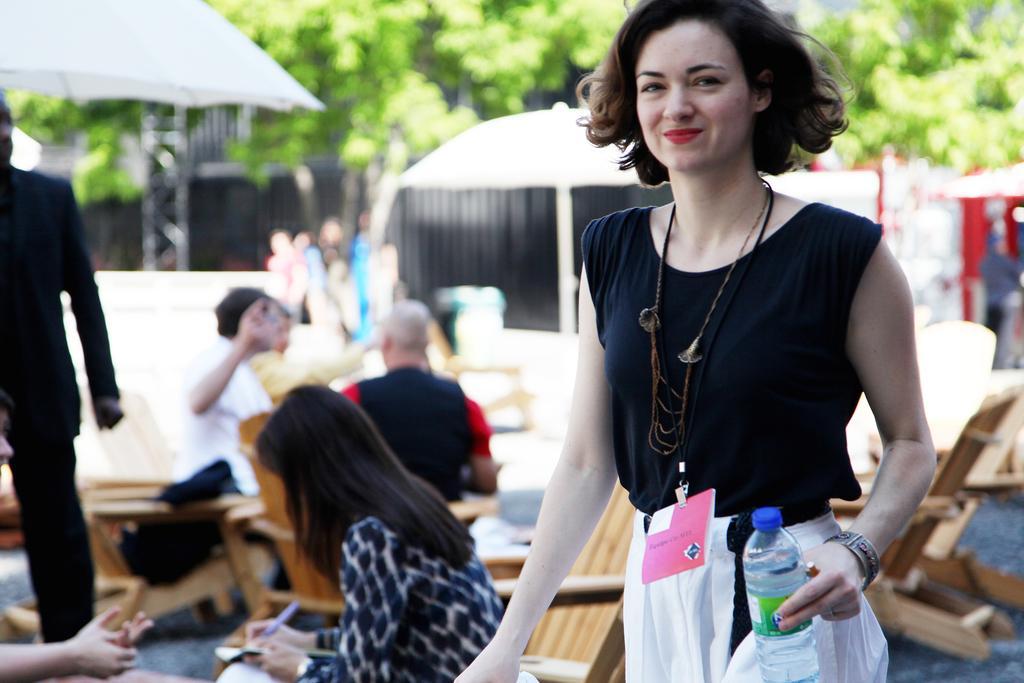Can you describe this image briefly? This picture shows a woman Standing and holding a water bottle in hand and we see few was seated on the chair and we see couple of trees on her back 